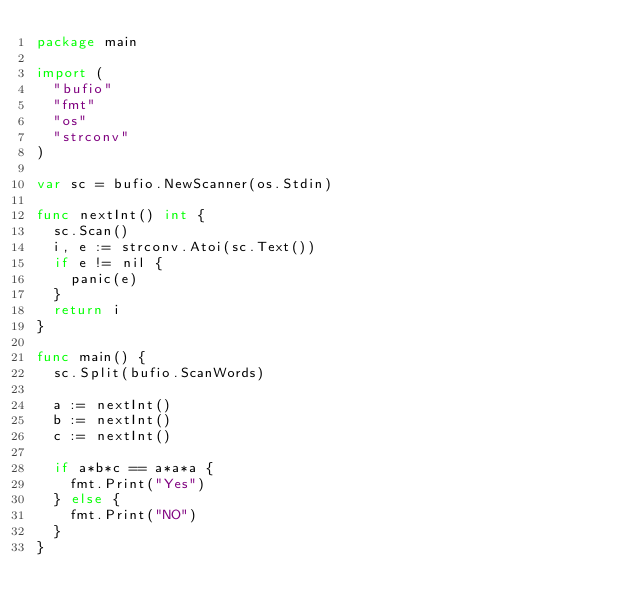Convert code to text. <code><loc_0><loc_0><loc_500><loc_500><_Go_>package main

import (
	"bufio"
	"fmt"
	"os"
	"strconv"
)

var sc = bufio.NewScanner(os.Stdin)

func nextInt() int {
	sc.Scan()
	i, e := strconv.Atoi(sc.Text())
	if e != nil {
		panic(e)
	}
	return i
}

func main() {
	sc.Split(bufio.ScanWords)

	a := nextInt()
	b := nextInt()
	c := nextInt()

	if a*b*c == a*a*a {
		fmt.Print("Yes")
	} else {
		fmt.Print("NO")
	}
}</code> 